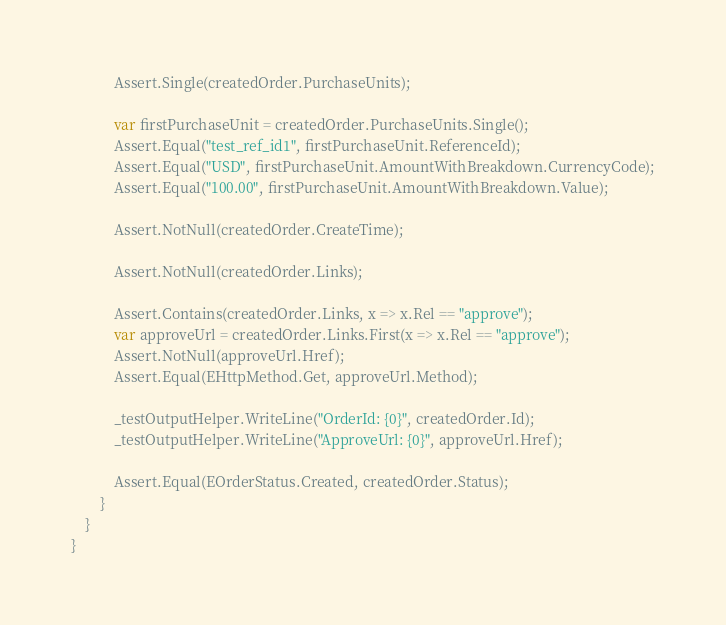Convert code to text. <code><loc_0><loc_0><loc_500><loc_500><_C#_>            Assert.Single(createdOrder.PurchaseUnits);

            var firstPurchaseUnit = createdOrder.PurchaseUnits.Single();
            Assert.Equal("test_ref_id1", firstPurchaseUnit.ReferenceId);
            Assert.Equal("USD", firstPurchaseUnit.AmountWithBreakdown.CurrencyCode);
            Assert.Equal("100.00", firstPurchaseUnit.AmountWithBreakdown.Value);

            Assert.NotNull(createdOrder.CreateTime);

            Assert.NotNull(createdOrder.Links);

            Assert.Contains(createdOrder.Links, x => x.Rel == "approve");
            var approveUrl = createdOrder.Links.First(x => x.Rel == "approve");
            Assert.NotNull(approveUrl.Href);
            Assert.Equal(EHttpMethod.Get, approveUrl.Method);

            _testOutputHelper.WriteLine("OrderId: {0}", createdOrder.Id);
            _testOutputHelper.WriteLine("ApproveUrl: {0}", approveUrl.Href);

            Assert.Equal(EOrderStatus.Created, createdOrder.Status);
        }
    }
}
</code> 